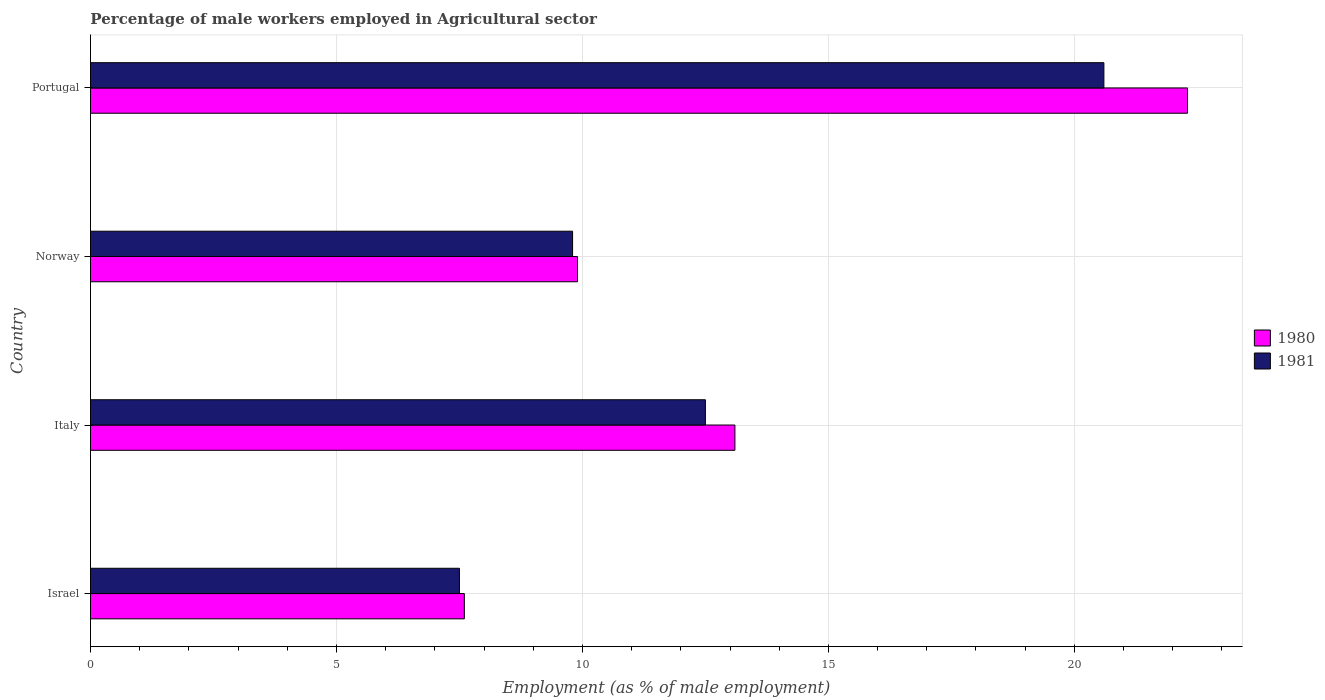How many different coloured bars are there?
Your answer should be compact. 2. Are the number of bars per tick equal to the number of legend labels?
Provide a succinct answer. Yes. Are the number of bars on each tick of the Y-axis equal?
Your answer should be compact. Yes. How many bars are there on the 2nd tick from the bottom?
Make the answer very short. 2. What is the label of the 2nd group of bars from the top?
Your response must be concise. Norway. What is the percentage of male workers employed in Agricultural sector in 1981 in Israel?
Give a very brief answer. 7.5. Across all countries, what is the maximum percentage of male workers employed in Agricultural sector in 1981?
Keep it short and to the point. 20.6. Across all countries, what is the minimum percentage of male workers employed in Agricultural sector in 1980?
Keep it short and to the point. 7.6. In which country was the percentage of male workers employed in Agricultural sector in 1981 maximum?
Keep it short and to the point. Portugal. In which country was the percentage of male workers employed in Agricultural sector in 1981 minimum?
Make the answer very short. Israel. What is the total percentage of male workers employed in Agricultural sector in 1980 in the graph?
Provide a short and direct response. 52.9. What is the difference between the percentage of male workers employed in Agricultural sector in 1981 in Norway and that in Portugal?
Your response must be concise. -10.8. What is the difference between the percentage of male workers employed in Agricultural sector in 1981 in Italy and the percentage of male workers employed in Agricultural sector in 1980 in Israel?
Make the answer very short. 4.9. What is the average percentage of male workers employed in Agricultural sector in 1980 per country?
Offer a terse response. 13.22. What is the difference between the percentage of male workers employed in Agricultural sector in 1981 and percentage of male workers employed in Agricultural sector in 1980 in Portugal?
Offer a very short reply. -1.7. What is the ratio of the percentage of male workers employed in Agricultural sector in 1981 in Norway to that in Portugal?
Give a very brief answer. 0.48. Is the percentage of male workers employed in Agricultural sector in 1981 in Israel less than that in Norway?
Offer a terse response. Yes. Is the difference between the percentage of male workers employed in Agricultural sector in 1981 in Italy and Portugal greater than the difference between the percentage of male workers employed in Agricultural sector in 1980 in Italy and Portugal?
Keep it short and to the point. Yes. What is the difference between the highest and the second highest percentage of male workers employed in Agricultural sector in 1981?
Make the answer very short. 8.1. What is the difference between the highest and the lowest percentage of male workers employed in Agricultural sector in 1980?
Offer a very short reply. 14.7. In how many countries, is the percentage of male workers employed in Agricultural sector in 1980 greater than the average percentage of male workers employed in Agricultural sector in 1980 taken over all countries?
Provide a short and direct response. 1. What does the 2nd bar from the bottom in Portugal represents?
Give a very brief answer. 1981. Are all the bars in the graph horizontal?
Your answer should be compact. Yes. How many countries are there in the graph?
Offer a very short reply. 4. What is the difference between two consecutive major ticks on the X-axis?
Give a very brief answer. 5. Does the graph contain any zero values?
Your answer should be compact. No. Does the graph contain grids?
Make the answer very short. Yes. How many legend labels are there?
Give a very brief answer. 2. What is the title of the graph?
Offer a terse response. Percentage of male workers employed in Agricultural sector. Does "2015" appear as one of the legend labels in the graph?
Your answer should be very brief. No. What is the label or title of the X-axis?
Offer a terse response. Employment (as % of male employment). What is the label or title of the Y-axis?
Provide a short and direct response. Country. What is the Employment (as % of male employment) in 1980 in Israel?
Ensure brevity in your answer.  7.6. What is the Employment (as % of male employment) in 1980 in Italy?
Your response must be concise. 13.1. What is the Employment (as % of male employment) of 1980 in Norway?
Offer a terse response. 9.9. What is the Employment (as % of male employment) of 1981 in Norway?
Keep it short and to the point. 9.8. What is the Employment (as % of male employment) in 1980 in Portugal?
Offer a very short reply. 22.3. What is the Employment (as % of male employment) of 1981 in Portugal?
Your answer should be very brief. 20.6. Across all countries, what is the maximum Employment (as % of male employment) in 1980?
Provide a succinct answer. 22.3. Across all countries, what is the maximum Employment (as % of male employment) in 1981?
Offer a very short reply. 20.6. Across all countries, what is the minimum Employment (as % of male employment) of 1980?
Provide a succinct answer. 7.6. What is the total Employment (as % of male employment) in 1980 in the graph?
Give a very brief answer. 52.9. What is the total Employment (as % of male employment) of 1981 in the graph?
Ensure brevity in your answer.  50.4. What is the difference between the Employment (as % of male employment) in 1980 in Israel and that in Italy?
Offer a very short reply. -5.5. What is the difference between the Employment (as % of male employment) in 1981 in Israel and that in Norway?
Ensure brevity in your answer.  -2.3. What is the difference between the Employment (as % of male employment) in 1980 in Israel and that in Portugal?
Offer a terse response. -14.7. What is the difference between the Employment (as % of male employment) in 1980 in Italy and that in Norway?
Make the answer very short. 3.2. What is the difference between the Employment (as % of male employment) of 1981 in Italy and that in Norway?
Make the answer very short. 2.7. What is the difference between the Employment (as % of male employment) in 1981 in Italy and that in Portugal?
Ensure brevity in your answer.  -8.1. What is the difference between the Employment (as % of male employment) in 1980 in Israel and the Employment (as % of male employment) in 1981 in Italy?
Your response must be concise. -4.9. What is the difference between the Employment (as % of male employment) in 1980 in Israel and the Employment (as % of male employment) in 1981 in Norway?
Your response must be concise. -2.2. What is the difference between the Employment (as % of male employment) in 1980 in Israel and the Employment (as % of male employment) in 1981 in Portugal?
Offer a terse response. -13. What is the difference between the Employment (as % of male employment) of 1980 in Italy and the Employment (as % of male employment) of 1981 in Norway?
Offer a very short reply. 3.3. What is the difference between the Employment (as % of male employment) of 1980 in Norway and the Employment (as % of male employment) of 1981 in Portugal?
Provide a succinct answer. -10.7. What is the average Employment (as % of male employment) in 1980 per country?
Provide a succinct answer. 13.22. What is the average Employment (as % of male employment) of 1981 per country?
Ensure brevity in your answer.  12.6. What is the difference between the Employment (as % of male employment) in 1980 and Employment (as % of male employment) in 1981 in Portugal?
Your answer should be very brief. 1.7. What is the ratio of the Employment (as % of male employment) in 1980 in Israel to that in Italy?
Offer a terse response. 0.58. What is the ratio of the Employment (as % of male employment) in 1981 in Israel to that in Italy?
Offer a terse response. 0.6. What is the ratio of the Employment (as % of male employment) of 1980 in Israel to that in Norway?
Your answer should be very brief. 0.77. What is the ratio of the Employment (as % of male employment) of 1981 in Israel to that in Norway?
Ensure brevity in your answer.  0.77. What is the ratio of the Employment (as % of male employment) of 1980 in Israel to that in Portugal?
Provide a succinct answer. 0.34. What is the ratio of the Employment (as % of male employment) of 1981 in Israel to that in Portugal?
Make the answer very short. 0.36. What is the ratio of the Employment (as % of male employment) in 1980 in Italy to that in Norway?
Make the answer very short. 1.32. What is the ratio of the Employment (as % of male employment) of 1981 in Italy to that in Norway?
Your answer should be very brief. 1.28. What is the ratio of the Employment (as % of male employment) of 1980 in Italy to that in Portugal?
Your answer should be very brief. 0.59. What is the ratio of the Employment (as % of male employment) in 1981 in Italy to that in Portugal?
Provide a short and direct response. 0.61. What is the ratio of the Employment (as % of male employment) in 1980 in Norway to that in Portugal?
Provide a succinct answer. 0.44. What is the ratio of the Employment (as % of male employment) in 1981 in Norway to that in Portugal?
Make the answer very short. 0.48. 